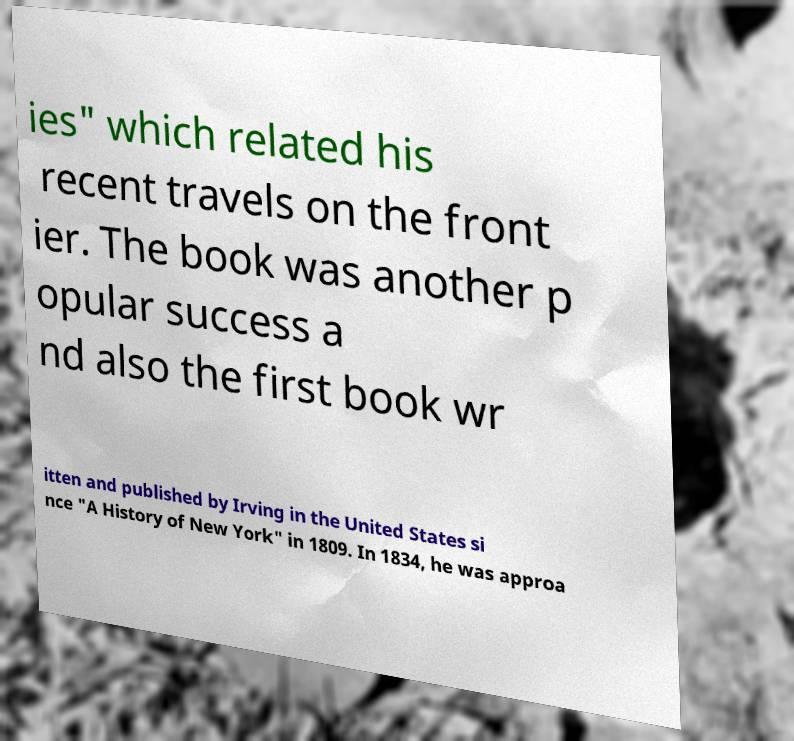Can you accurately transcribe the text from the provided image for me? ies" which related his recent travels on the front ier. The book was another p opular success a nd also the first book wr itten and published by Irving in the United States si nce "A History of New York" in 1809. In 1834, he was approa 